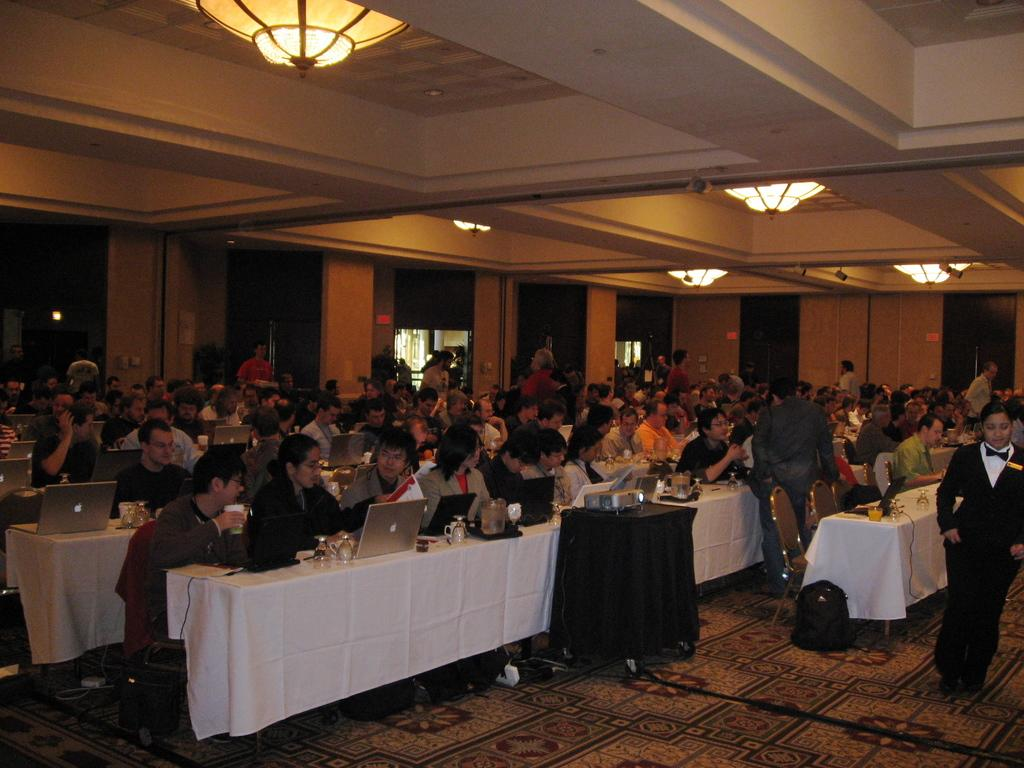How many people are present in the image? There are many people in the image. What can be seen on the tables in the image? There are objects on the tables in the image. Can you describe any lighting fixtures in the image? There are lamps in the image. What is present on the walls in the image? There are objects on the walls in the image. What type of wine is being served at the desk in the image? There is no desk or wine present in the image. 